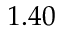<formula> <loc_0><loc_0><loc_500><loc_500>1 . 4 0</formula> 